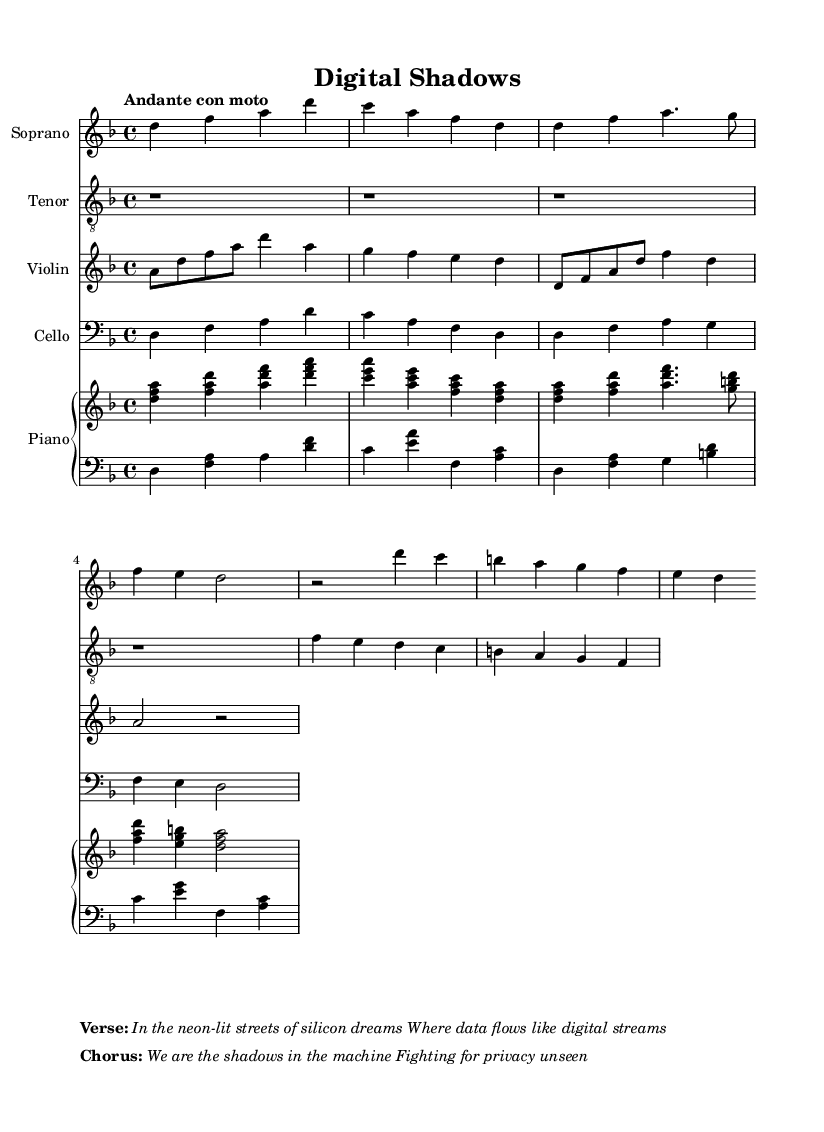What is the key signature of this music? The key signature indicated at the beginning of the piece is D minor, which typically has one flat (B flat). This can be deduced from the initial indication in the score labeled with the key at the start of the global section.
Answer: D minor What is the time signature of this music? The time signature is noted at the beginning of the piece as 4/4. This indicates that there are four beats in each measure and the quarter note receives one beat. It can be found in the global section of the score.
Answer: 4/4 What is the tempo marking of this music? The tempo marking "Andante con moto" is specified in the global section, indicating a moderately slow tempo with some movement. This can be referenced by looking at the tempo indication placed above the staff.
Answer: Andante con moto How many vocal parts are there? Analyzing the score, we observe two vocal parts listed, specifically a Soprano and a Tenor. These parts are explicitly stated at the beginning of their respective staff lines in the score.
Answer: Two What is the title of the piece? The title "Digital Shadows" is clearly presented at the top of the score under the header section. It reflects the theme and subject of the piece.
Answer: Digital Shadows What is the primary theme conveyed in the verse? The primary theme reflected in the verse discusses the imagery of digital environments and data, highlighted by phrases such as "neon-lit streets" and "data flows". This can be inferred from the specific wording chosen in the verse markup section of the sheet.
Answer: Digital environments 